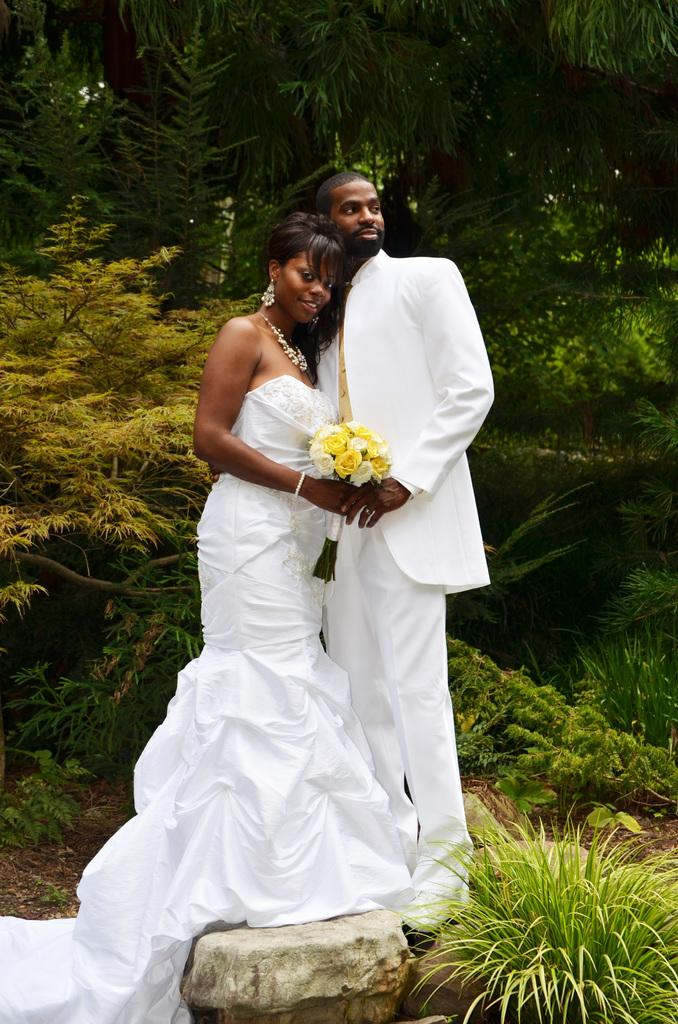How many people are in the image? There are two persons in the image. What are the persons wearing? Both persons are wearing white dress. What are the persons holding in the image? The persons are holding a bouquet. What can be seen at the bottom of the image? There is a rock at the bottom of the image. What type of vegetation is visible in the background of the image? There are trees and plants in the background of the image. Can you see a cracker being eaten by a bird in the image? There is no cracker or bird present in the image. Is there an airplane flying in the background of the image? No, there is no airplane visible in the image. 